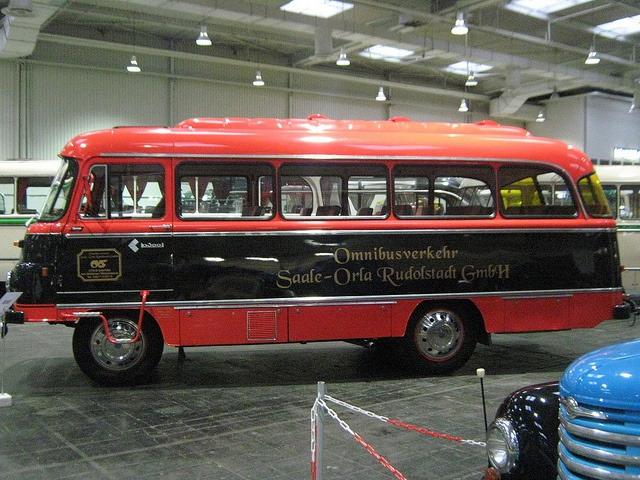Describe the objects in this image and their specific colors. I can see bus in gray, black, brown, and maroon tones and truck in gray, black, and lightblue tones in this image. 